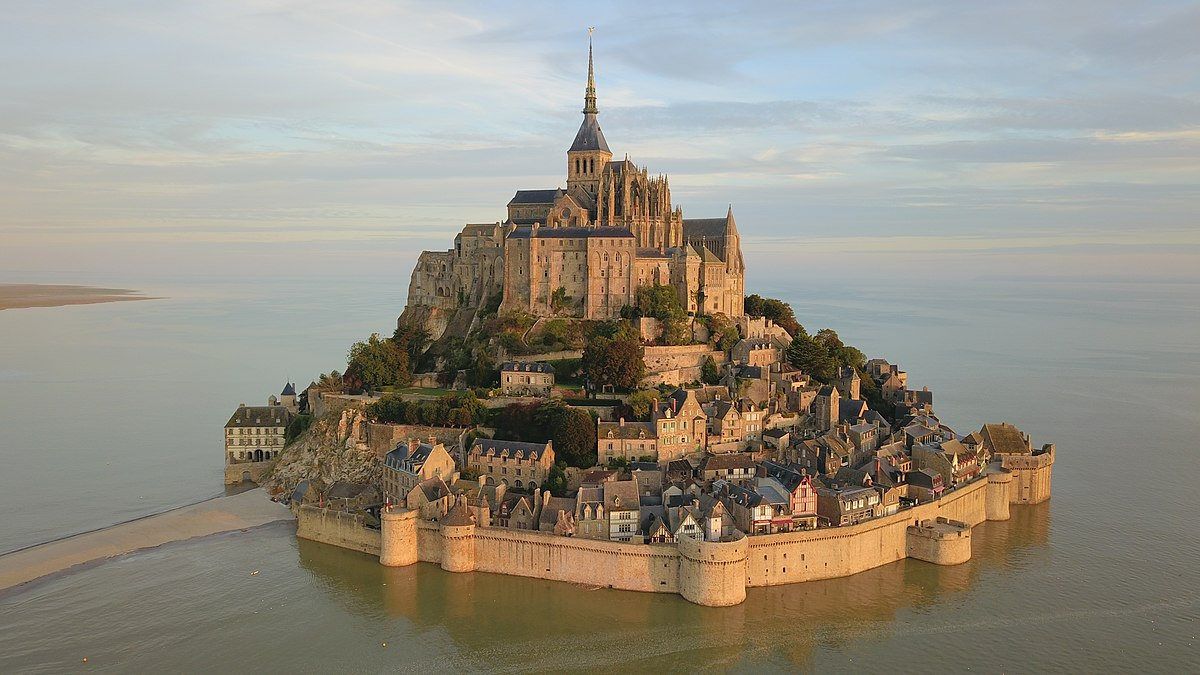What's happening in the scene?
 The image captures an aerial view of Mont St Michel, a historic island commune in Normandy, France. The island is surrounded by the shimmering blue water and is connected to the mainland by a causeway. Dominating the island is a large Gothic abbey with a tall spire that pierces the sky. The abbey is encircled by a fortified wall, providing a sense of security and grandeur. Nestled within these fortifications is a quaint village, characterized by stone buildings and narrow streets that weave a labyrinth-like pattern. The colors in the image are predominantly beige and gray, reflecting the historic stone architecture, with patches of greenery adding a touch of nature. The perspective of the image is from above, offering a comprehensive view of the island and its surrounding landscape. This perspective allows one to appreciate the strategic location and impressive architecture of this renowned landmark. 